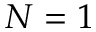Convert formula to latex. <formula><loc_0><loc_0><loc_500><loc_500>N = 1</formula> 